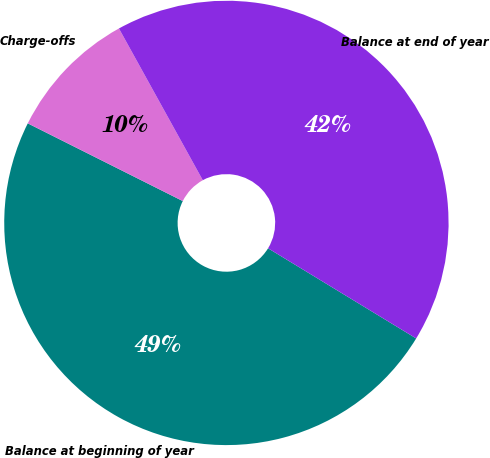Convert chart. <chart><loc_0><loc_0><loc_500><loc_500><pie_chart><fcel>Balance at beginning of year<fcel>Charge-offs<fcel>Balance at end of year<nl><fcel>48.7%<fcel>9.57%<fcel>41.74%<nl></chart> 